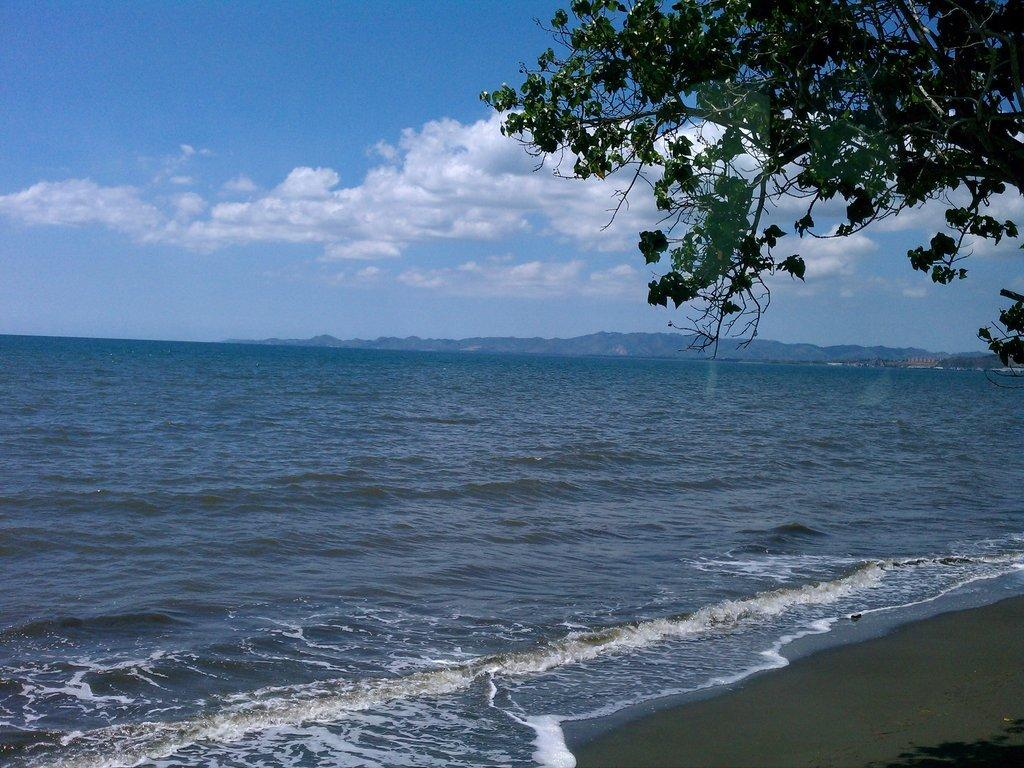What type of natural feature is visible in the image? There is an ocean in the image. What other natural element can be seen in the image? There is a tree in the image. How would you describe the sky in the image? The sky is cloudy in the image. What type of prose is written on the tree trunk in the image? There is no prose written on the tree trunk in the image; it is a natural element without any text. 